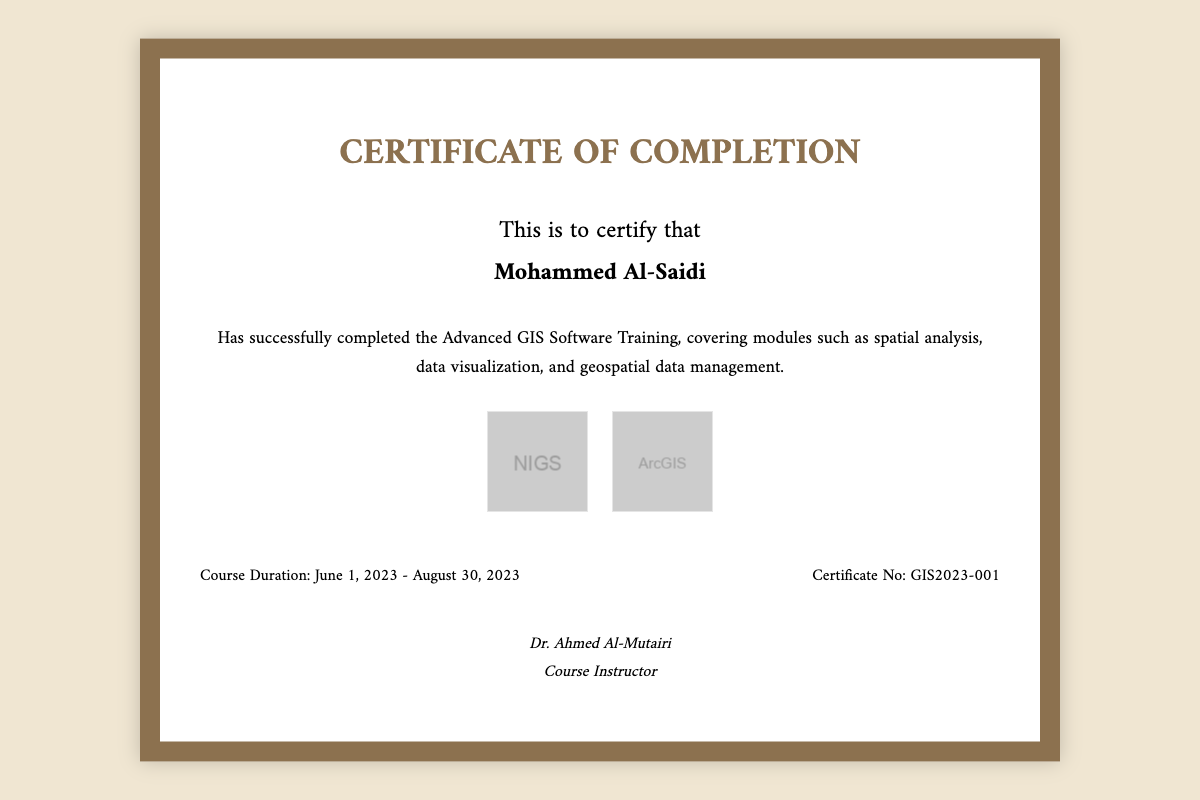What is the recipient's name? The recipient's name is prominently displayed in the document.
Answer: Mohammed Al-Saidi What is the course title? The title of the course is mentioned in the introductory part of the document.
Answer: Advanced GIS Software Training What are the completion dates of the course? The document specifies the start and end dates of the course in the details section.
Answer: June 1, 2023 - August 30, 2023 Who is the course instructor? The name of the course instructor is located at the bottom of the document near the signature.
Answer: Dr. Ahmed Al-Mutairi What certification number is assigned to this document? The certificate number can be found in the details section of the certificate.
Answer: GIS2023-001 What type of training does this certificate represent? The document identifies the nature of training provided through its title and description.
Answer: Advanced GIS Software Training How many logos are presented in the document? The logos of the training institute and the GIS software are displayed together.
Answer: Two What is the background color of the certificate? The background color of the certificate can be observed from the styling details outlined in the code.
Answer: White What font style is used for the heading? The font name and styling are defined at the beginning of the document's styles.
Answer: Amiri 